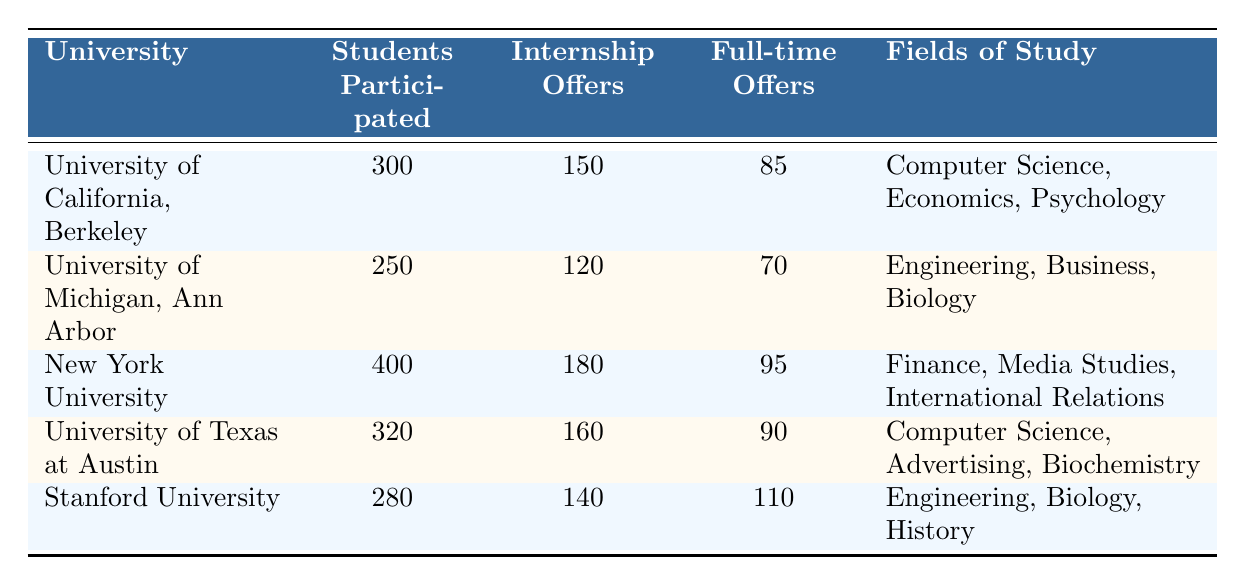What is the total number of internship offers received by students across all universities? To find the total number of internship offers, we sum the internship offers from each university: 150 (UC Berkeley) + 120 (UMich) + 180 (NYU) + 160 (UT Austin) + 140 (Stanford) = 850
Answer: 850 Which university had the highest number of full-time offers received? By comparing the full-time offers from each university, we see that Stanford University received 110 full-time offers, which is the highest among all listed universities.
Answer: Stanford University How many more internship offers were received than full-time offers at New York University? At New York University, 180 internship offers were received, and 95 full-time offers were received. The difference is 180 - 95 = 85.
Answer: 85 Is it true that the University of California, Berkeley received more internship offers than the University of Michigan, Ann Arbor? Yes, UC Berkeley received 150 internship offers, while the University of Michigan received 120. Therefore, UC Berkeley received more internship offers.
Answer: Yes What percentage of students at the University of Texas at Austin received internship offers? The University of Texas at Austin had 320 students participating and received 160 internship offers. To find the percentage: (160/320) * 100% = 50%.
Answer: 50% Which university had the lowest percentage of students receiving full-time offers, and what was that percentage? First, we calculate the percentage of students receiving full-time offers for each university: UC Berkeley (85/300) * 100% = 28.33%, UMich (70/250) * 100% = 28%, NYU (95/400) * 100% = 23.75%, UT Austin (90/320) * 100% = 28.13%, Stanford (110/280) * 100% = 39.29%. New York University has the lowest percentage at 23.75%.
Answer: New York University, 23.75% What is the average number of full-time offers received per participating student across all universities? First, we find the total number of full-time offers, which is 85 + 70 + 95 + 90 + 110 = 450. Next, we find the total number of students who participated: 300 + 250 + 400 + 320 + 280 = 1550. Finally, we calculate the average: 450 / 1550 ≈ 0.29 full-time offers per student.
Answer: Approximately 0.29 How many universities had more internship offers than full-time offers? By reviewing the data, we see that all universities (Berkeley, Michigan, NYU, Texas, and Stanford) received more internship offers than full-time offers, indicating a trend where internships are more prevalent.
Answer: 5 